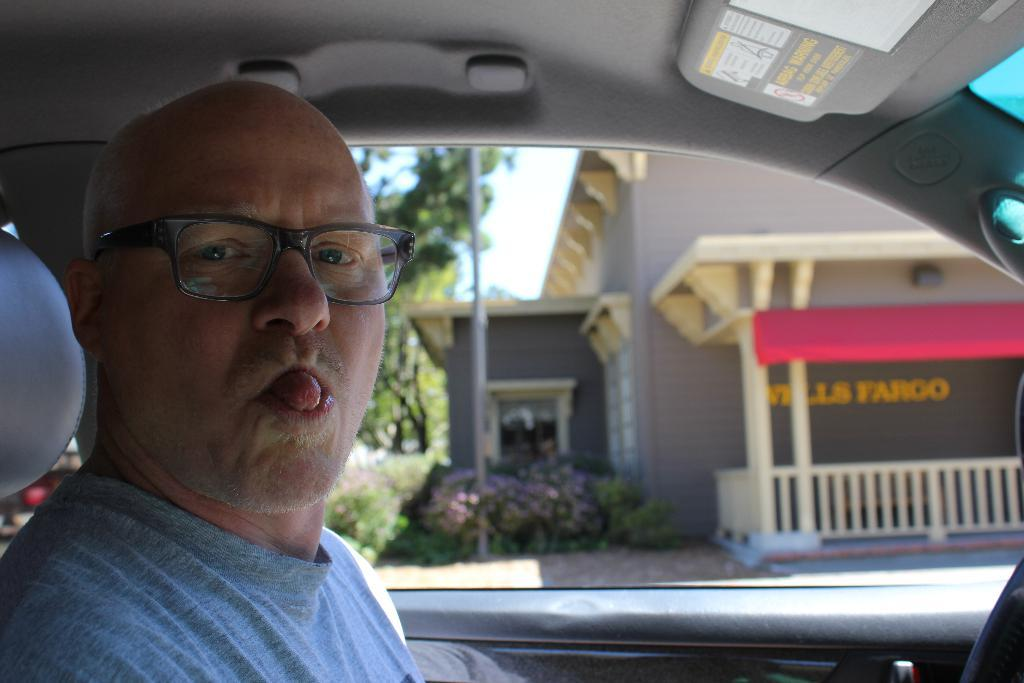What is the man in the image doing? The man is sitting inside the car. What can be seen in the background of the image? There are trees, plants, and a building in the background of the image. What type of nut is the man cracking in the image? There is no nut present in the image; the man is sitting inside the car. 